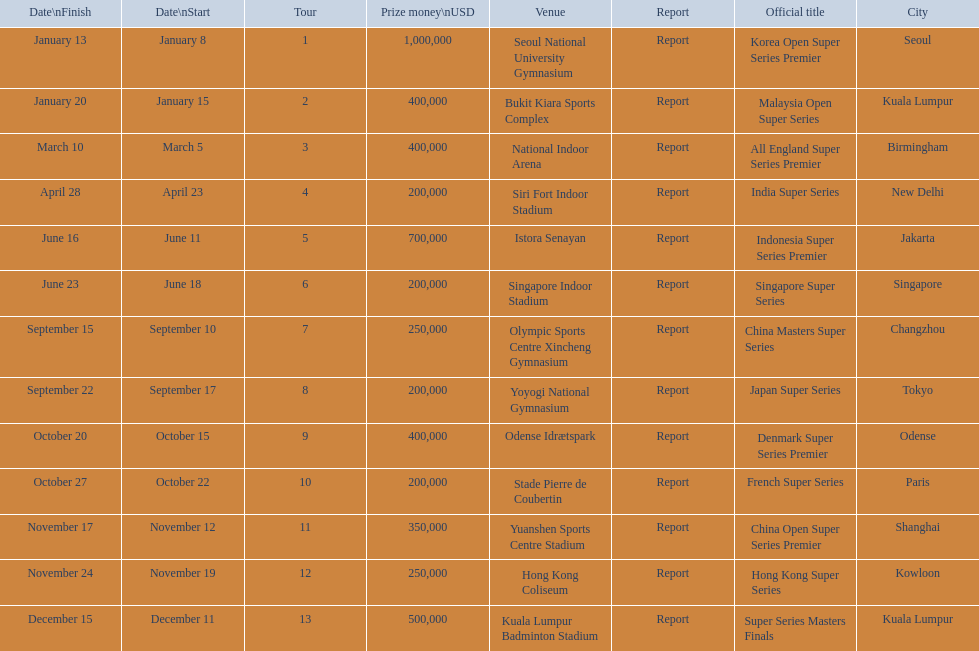What are all the tours? Korea Open Super Series Premier, Malaysia Open Super Series, All England Super Series Premier, India Super Series, Indonesia Super Series Premier, Singapore Super Series, China Masters Super Series, Japan Super Series, Denmark Super Series Premier, French Super Series, China Open Super Series Premier, Hong Kong Super Series, Super Series Masters Finals. What were the start dates of these tours? January 8, January 15, March 5, April 23, June 11, June 18, September 10, September 17, October 15, October 22, November 12, November 19, December 11. Of these, which is in december? December 11. Which tour started on this date? Super Series Masters Finals. 